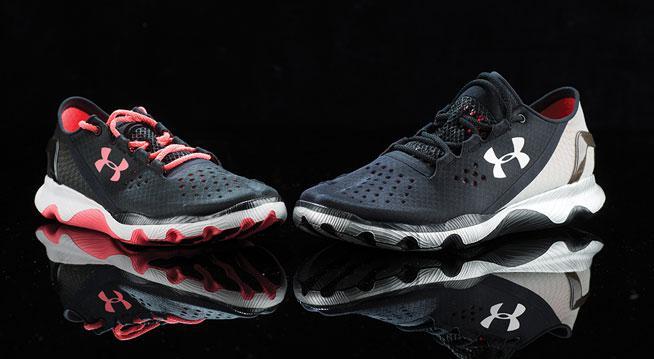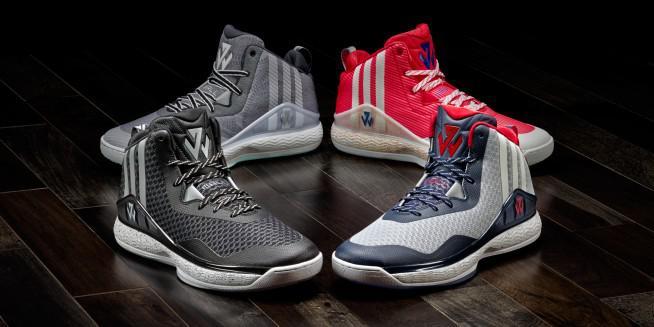The first image is the image on the left, the second image is the image on the right. Given the left and right images, does the statement "There are fewer than four shoes in total." hold true? Answer yes or no. No. The first image is the image on the left, the second image is the image on the right. For the images shown, is this caption "There are more shoes in the image on the right." true? Answer yes or no. Yes. 